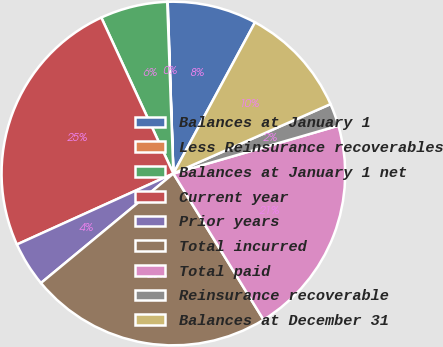Convert chart to OTSL. <chart><loc_0><loc_0><loc_500><loc_500><pie_chart><fcel>Balances at January 1<fcel>Less Reinsurance recoverables<fcel>Balances at January 1 net<fcel>Current year<fcel>Prior years<fcel>Total incurred<fcel>Total paid<fcel>Reinsurance recoverable<fcel>Balances at December 31<nl><fcel>8.41%<fcel>0.04%<fcel>6.32%<fcel>24.89%<fcel>4.22%<fcel>22.8%<fcel>20.7%<fcel>2.13%<fcel>10.5%<nl></chart> 